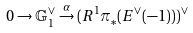Convert formula to latex. <formula><loc_0><loc_0><loc_500><loc_500>0 \to \mathbb { G } _ { 1 } ^ { \vee } \overset { \alpha } \to ( R ^ { 1 } \pi _ { * } ( E ^ { \vee } ( - 1 ) ) ) ^ { \vee }</formula> 